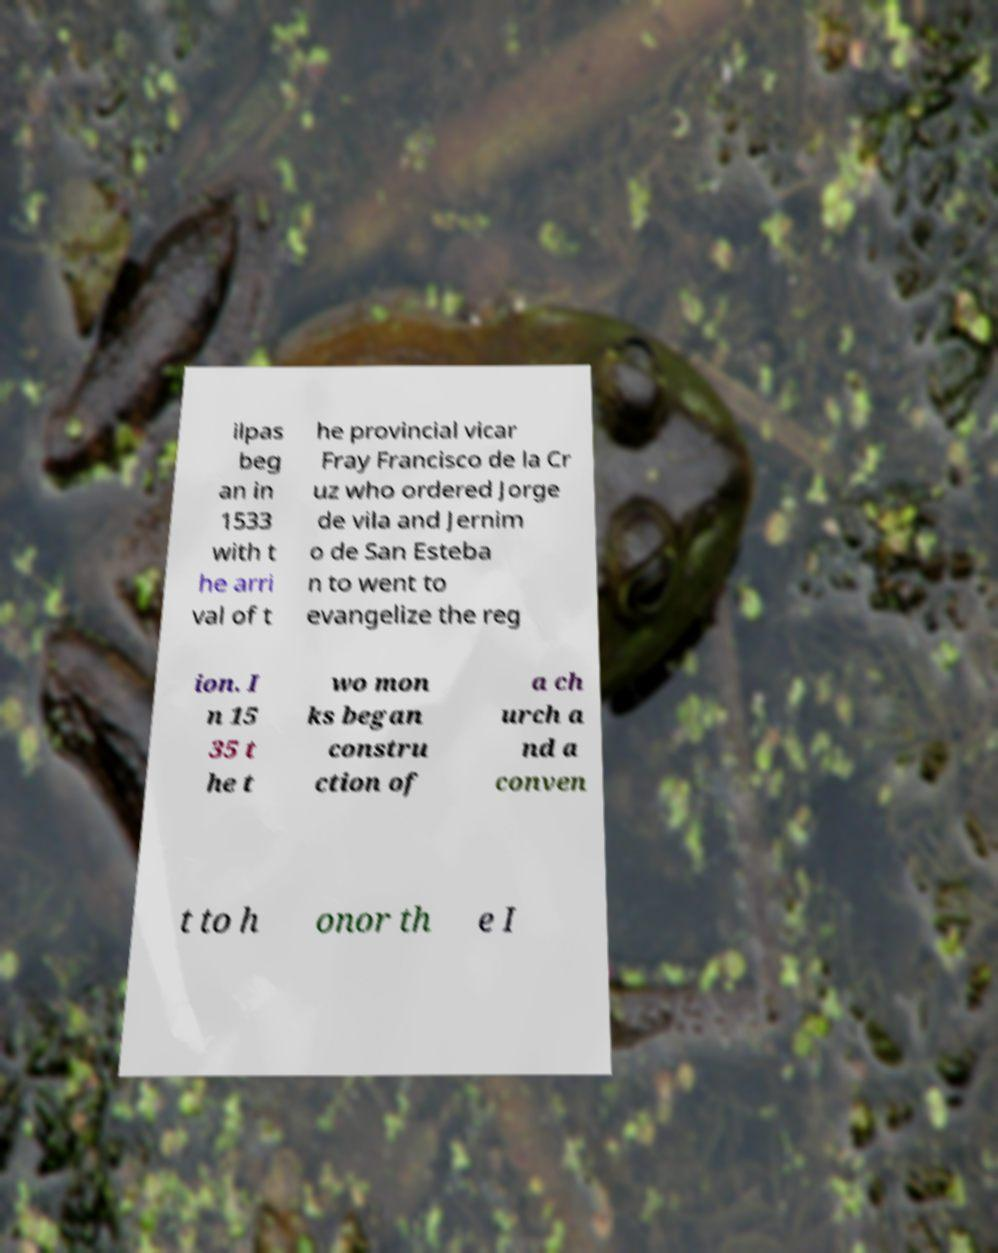I need the written content from this picture converted into text. Can you do that? ilpas beg an in 1533 with t he arri val of t he provincial vicar Fray Francisco de la Cr uz who ordered Jorge de vila and Jernim o de San Esteba n to went to evangelize the reg ion. I n 15 35 t he t wo mon ks began constru ction of a ch urch a nd a conven t to h onor th e I 